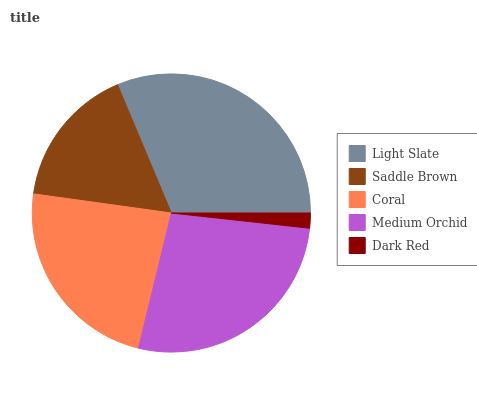Is Dark Red the minimum?
Answer yes or no. Yes. Is Light Slate the maximum?
Answer yes or no. Yes. Is Saddle Brown the minimum?
Answer yes or no. No. Is Saddle Brown the maximum?
Answer yes or no. No. Is Light Slate greater than Saddle Brown?
Answer yes or no. Yes. Is Saddle Brown less than Light Slate?
Answer yes or no. Yes. Is Saddle Brown greater than Light Slate?
Answer yes or no. No. Is Light Slate less than Saddle Brown?
Answer yes or no. No. Is Coral the high median?
Answer yes or no. Yes. Is Coral the low median?
Answer yes or no. Yes. Is Light Slate the high median?
Answer yes or no. No. Is Dark Red the low median?
Answer yes or no. No. 